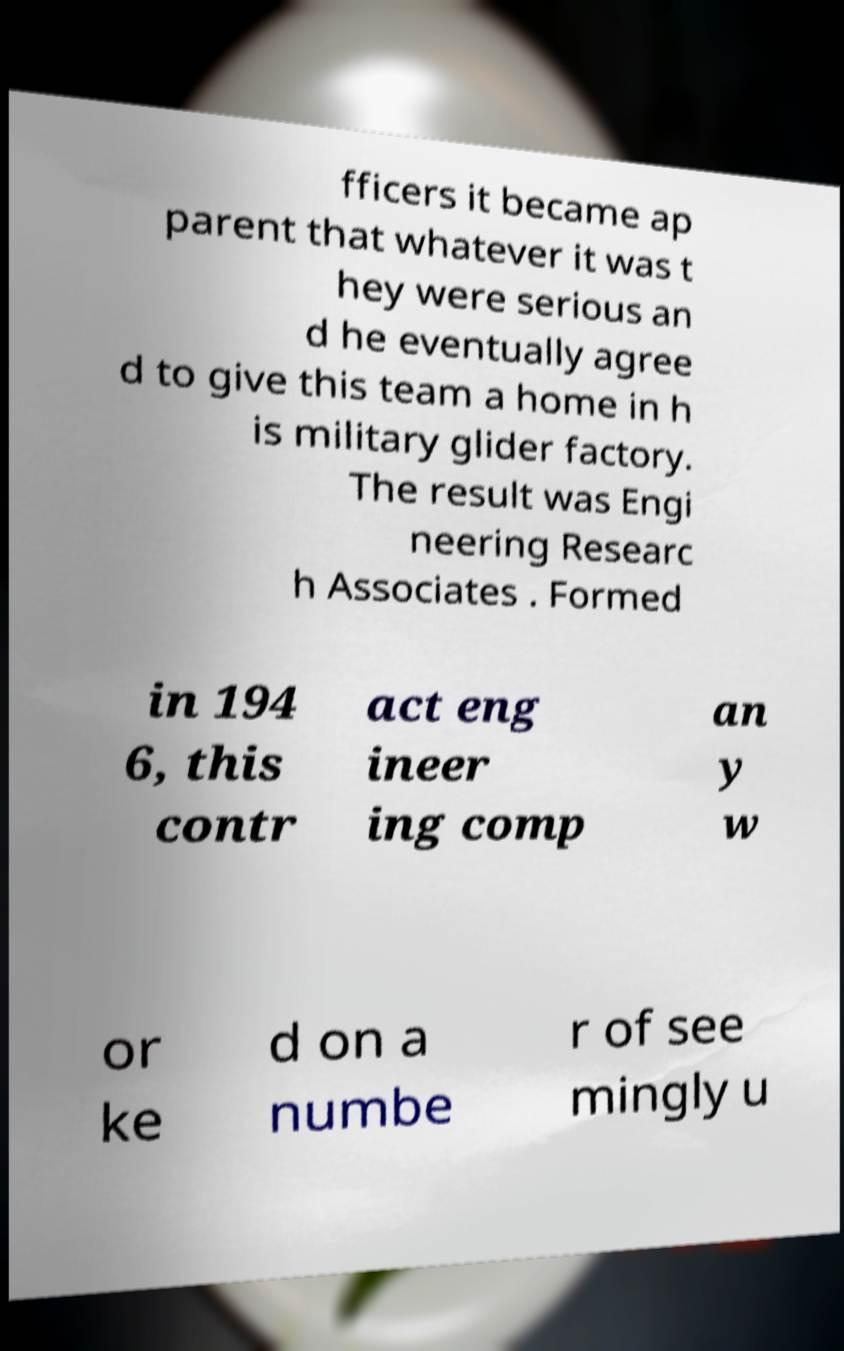Could you extract and type out the text from this image? fficers it became ap parent that whatever it was t hey were serious an d he eventually agree d to give this team a home in h is military glider factory. The result was Engi neering Researc h Associates . Formed in 194 6, this contr act eng ineer ing comp an y w or ke d on a numbe r of see mingly u 